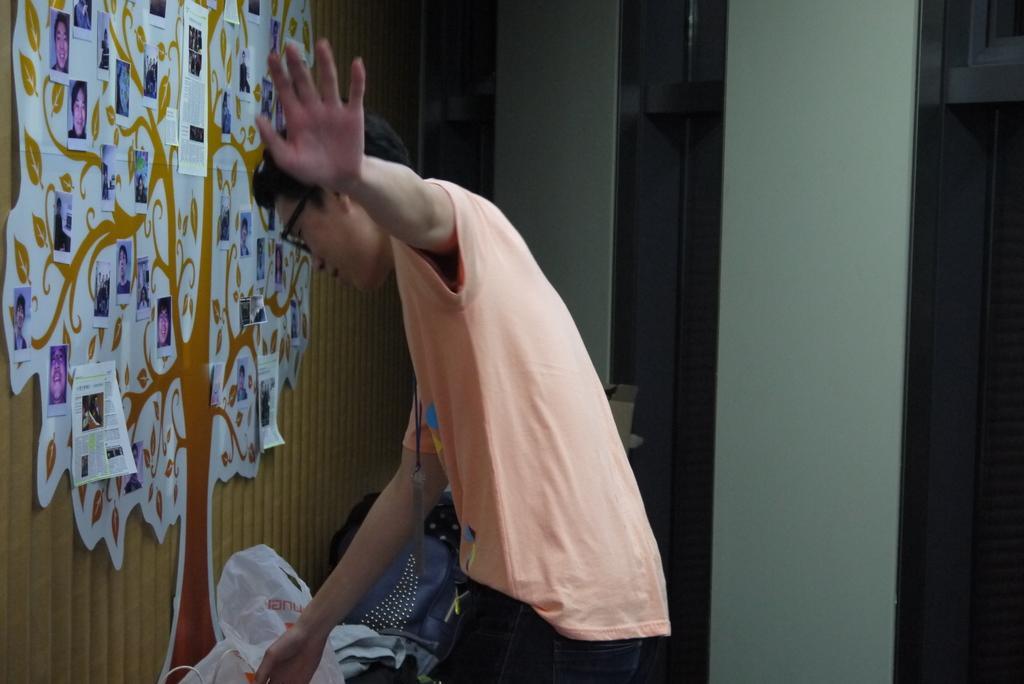Please provide a concise description of this image. This image consists of a man wearing a T-shirt. On the left, there is a tree poster on the wall. On the left, we can see a carry bag. And we can see photographs on the wall. 